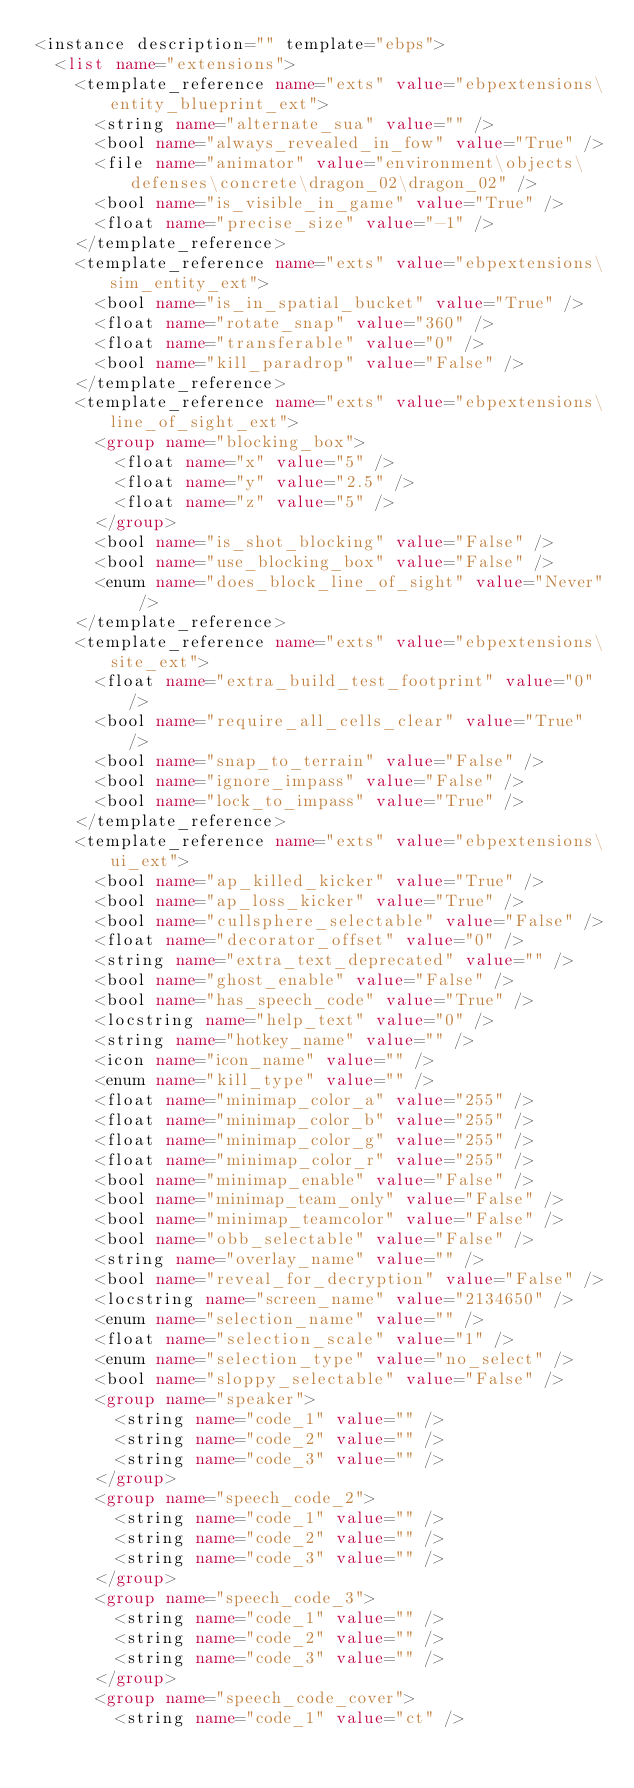<code> <loc_0><loc_0><loc_500><loc_500><_XML_><instance description="" template="ebps">
	<list name="extensions">
		<template_reference name="exts" value="ebpextensions\entity_blueprint_ext">
			<string name="alternate_sua" value="" />
			<bool name="always_revealed_in_fow" value="True" />
			<file name="animator" value="environment\objects\defenses\concrete\dragon_02\dragon_02" />
			<bool name="is_visible_in_game" value="True" />
			<float name="precise_size" value="-1" />
		</template_reference>
		<template_reference name="exts" value="ebpextensions\sim_entity_ext">
			<bool name="is_in_spatial_bucket" value="True" />
			<float name="rotate_snap" value="360" />
			<float name="transferable" value="0" />
			<bool name="kill_paradrop" value="False" />
		</template_reference>
		<template_reference name="exts" value="ebpextensions\line_of_sight_ext">
			<group name="blocking_box">
				<float name="x" value="5" />
				<float name="y" value="2.5" />
				<float name="z" value="5" />
			</group>
			<bool name="is_shot_blocking" value="False" />
			<bool name="use_blocking_box" value="False" />
			<enum name="does_block_line_of_sight" value="Never" />
		</template_reference>
		<template_reference name="exts" value="ebpextensions\site_ext">
			<float name="extra_build_test_footprint" value="0" />
			<bool name="require_all_cells_clear" value="True" />
			<bool name="snap_to_terrain" value="False" />
			<bool name="ignore_impass" value="False" />
			<bool name="lock_to_impass" value="True" />
		</template_reference>
		<template_reference name="exts" value="ebpextensions\ui_ext">
			<bool name="ap_killed_kicker" value="True" />
			<bool name="ap_loss_kicker" value="True" />
			<bool name="cullsphere_selectable" value="False" />
			<float name="decorator_offset" value="0" />
			<string name="extra_text_deprecated" value="" />
			<bool name="ghost_enable" value="False" />
			<bool name="has_speech_code" value="True" />
			<locstring name="help_text" value="0" />
			<string name="hotkey_name" value="" />
			<icon name="icon_name" value="" />
			<enum name="kill_type" value="" />
			<float name="minimap_color_a" value="255" />
			<float name="minimap_color_b" value="255" />
			<float name="minimap_color_g" value="255" />
			<float name="minimap_color_r" value="255" />
			<bool name="minimap_enable" value="False" />
			<bool name="minimap_team_only" value="False" />
			<bool name="minimap_teamcolor" value="False" />
			<bool name="obb_selectable" value="False" />
			<string name="overlay_name" value="" />
			<bool name="reveal_for_decryption" value="False" />
			<locstring name="screen_name" value="2134650" />
			<enum name="selection_name" value="" />
			<float name="selection_scale" value="1" />
			<enum name="selection_type" value="no_select" />
			<bool name="sloppy_selectable" value="False" />
			<group name="speaker">
				<string name="code_1" value="" />
				<string name="code_2" value="" />
				<string name="code_3" value="" />
			</group>
			<group name="speech_code_2">
				<string name="code_1" value="" />
				<string name="code_2" value="" />
				<string name="code_3" value="" />
			</group>
			<group name="speech_code_3">
				<string name="code_1" value="" />
				<string name="code_2" value="" />
				<string name="code_3" value="" />
			</group>
			<group name="speech_code_cover">
				<string name="code_1" value="ct" /></code> 